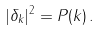<formula> <loc_0><loc_0><loc_500><loc_500>| \delta _ { k } | ^ { 2 } = P ( k ) \, .</formula> 